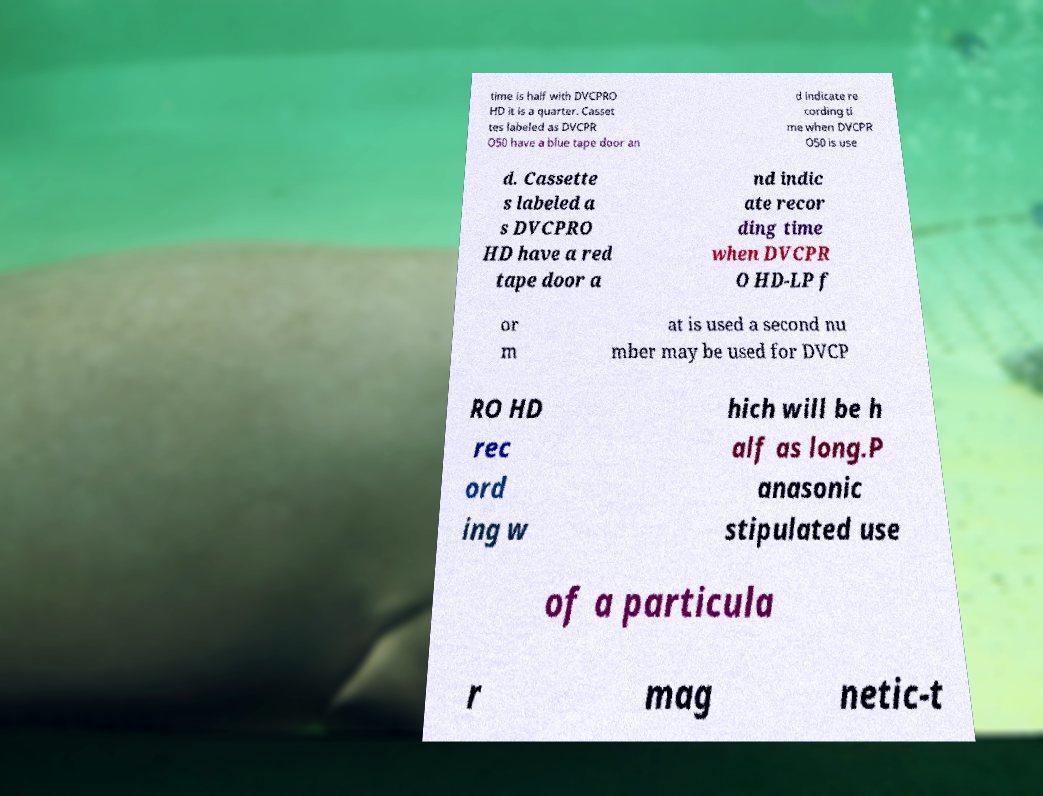For documentation purposes, I need the text within this image transcribed. Could you provide that? time is half with DVCPRO HD it is a quarter. Casset tes labeled as DVCPR O50 have a blue tape door an d indicate re cording ti me when DVCPR O50 is use d. Cassette s labeled a s DVCPRO HD have a red tape door a nd indic ate recor ding time when DVCPR O HD-LP f or m at is used a second nu mber may be used for DVCP RO HD rec ord ing w hich will be h alf as long.P anasonic stipulated use of a particula r mag netic-t 